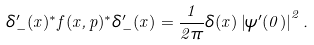<formula> <loc_0><loc_0><loc_500><loc_500>\delta _ { - } ^ { \prime } ( x ) ^ { * } f ( x , p ) ^ { * } \delta _ { - } ^ { \prime } ( x ) = \frac { 1 } { 2 \pi } \delta ( x ) \left | \psi ^ { \prime } ( 0 ) \right | ^ { 2 } .</formula> 